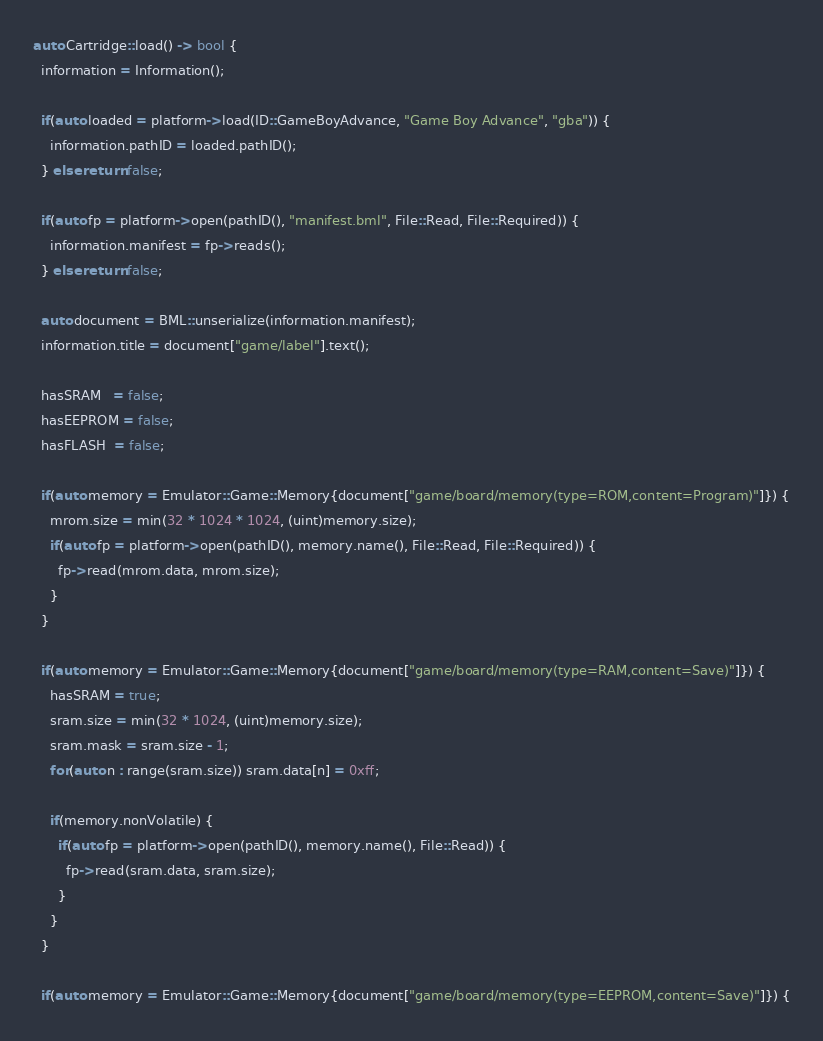Convert code to text. <code><loc_0><loc_0><loc_500><loc_500><_C++_>auto Cartridge::load() -> bool {
  information = Information();

  if(auto loaded = platform->load(ID::GameBoyAdvance, "Game Boy Advance", "gba")) {
    information.pathID = loaded.pathID();
  } else return false;

  if(auto fp = platform->open(pathID(), "manifest.bml", File::Read, File::Required)) {
    information.manifest = fp->reads();
  } else return false;

  auto document = BML::unserialize(information.manifest);
  information.title = document["game/label"].text();

  hasSRAM   = false;
  hasEEPROM = false;
  hasFLASH  = false;

  if(auto memory = Emulator::Game::Memory{document["game/board/memory(type=ROM,content=Program)"]}) {
    mrom.size = min(32 * 1024 * 1024, (uint)memory.size);
    if(auto fp = platform->open(pathID(), memory.name(), File::Read, File::Required)) {
      fp->read(mrom.data, mrom.size);
    }
  }

  if(auto memory = Emulator::Game::Memory{document["game/board/memory(type=RAM,content=Save)"]}) {
    hasSRAM = true;
    sram.size = min(32 * 1024, (uint)memory.size);
    sram.mask = sram.size - 1;
    for(auto n : range(sram.size)) sram.data[n] = 0xff;

    if(memory.nonVolatile) {
      if(auto fp = platform->open(pathID(), memory.name(), File::Read)) {
        fp->read(sram.data, sram.size);
      }
    }
  }

  if(auto memory = Emulator::Game::Memory{document["game/board/memory(type=EEPROM,content=Save)"]}) {</code> 